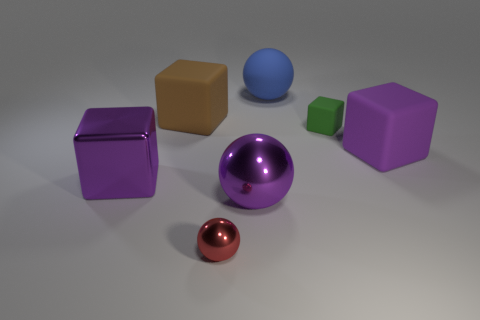What number of other objects are there of the same shape as the brown matte object?
Your response must be concise. 3. Is the color of the large matte thing in front of the large brown object the same as the small metallic object?
Keep it short and to the point. No. Is there another metallic block of the same color as the big metal cube?
Offer a very short reply. No. How many large things are in front of the blue matte thing?
Your response must be concise. 4. How many other things are there of the same size as the green block?
Keep it short and to the point. 1. Is the material of the large purple cube that is on the left side of the small red ball the same as the purple sphere in front of the big matte ball?
Your answer should be compact. Yes. What color is the metallic block that is the same size as the rubber ball?
Offer a very short reply. Purple. Are there any other things of the same color as the small rubber thing?
Provide a short and direct response. No. There is a purple metallic object right of the tiny thing in front of the big rubber thing that is in front of the green object; what size is it?
Provide a short and direct response. Large. There is a big matte thing that is both to the right of the red metallic object and on the left side of the big purple matte object; what is its color?
Give a very brief answer. Blue. 